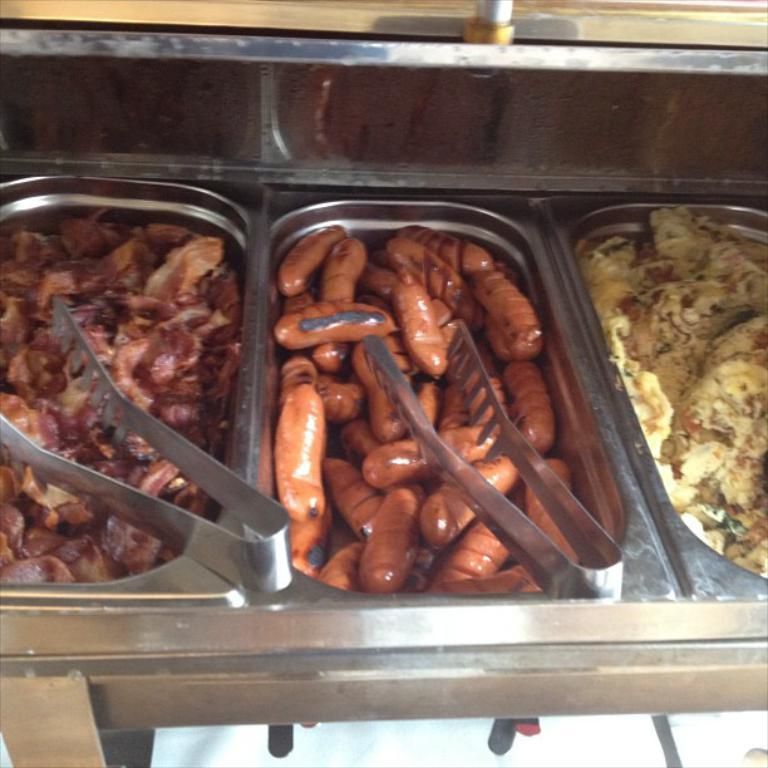What types of items can be seen in the image? There are food items in the image. How are the food items stored or contained? The food items are in food containers. What utensil is visible in the image? There are tongs visible in the image. What type of apparel is being worn by the pickle in the image? There are no pickles or any apparel present in the image. 